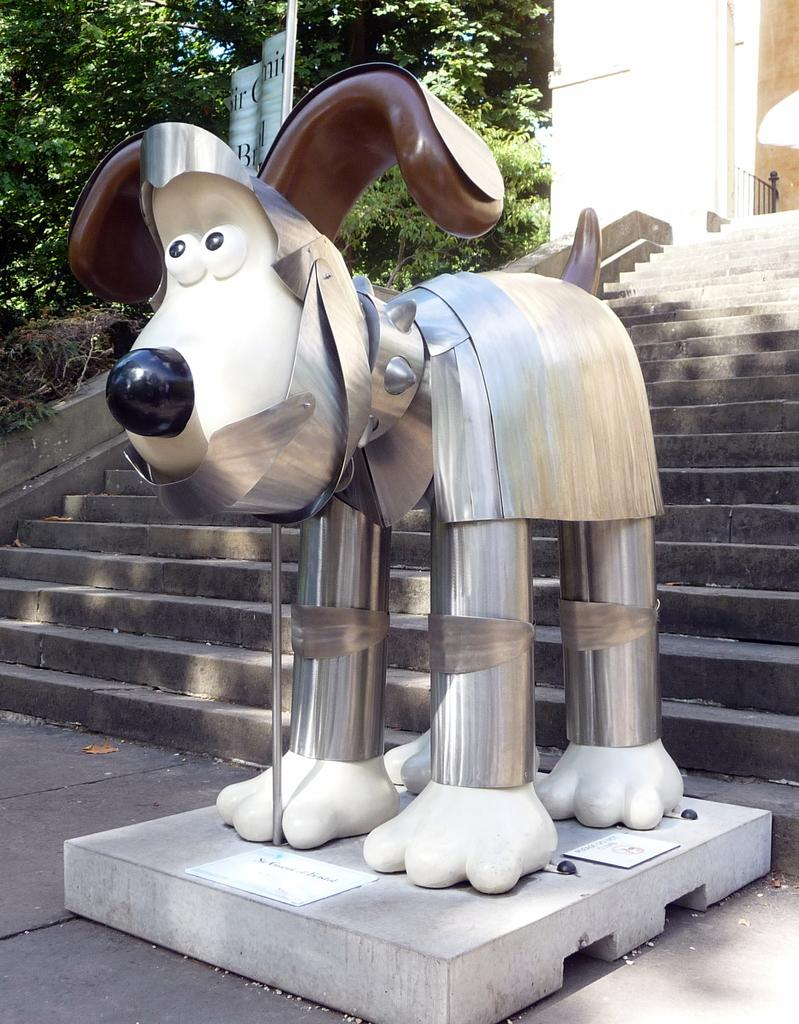What is the main structure visible in the image? There is a building in the image. What can be seen in the background of the image? There are trees in the background of the image. What is the board with text used for in the image? The board with text might be used for displaying information or advertising. How many sticks are being used to hold the vase in the image? There is no vase or sticks present in the image. 